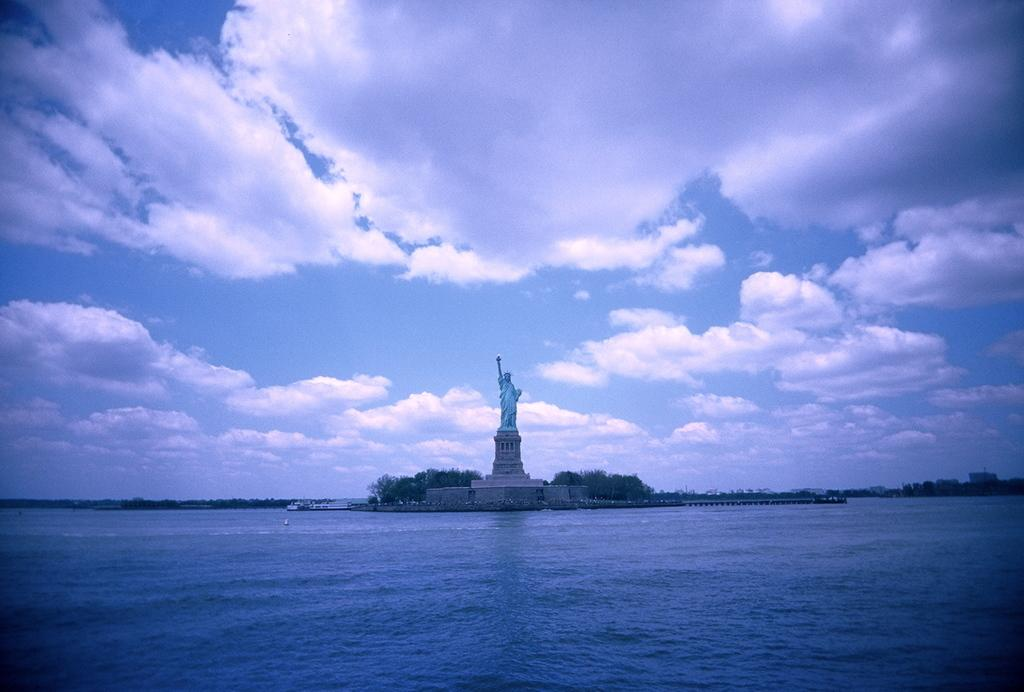What is located in the front of the image? There is water in the front of the image. What famous landmark can be seen in the background? The Statue of Liberty is visible in the background. What type of natural vegetation is present in the background? There are trees in the background. What type of man-made structures are visible in the background? There are buildings in the background. What can be seen in the sky in the background? Clouds and the sky are visible in the background. What flavor of snake is slithering through the water in the image? There are no snakes present in the image; it features water in the front and the Statue of Liberty in the background. What type of bell can be heard ringing in the image? There is no bell present in the image, and therefore no sound can be heard. 